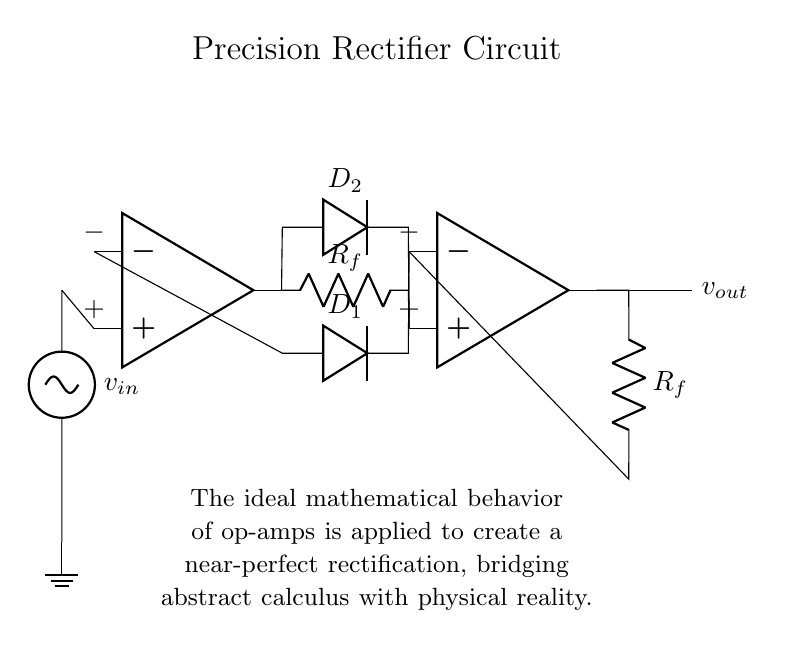What are the main components in this circuit? The circuit consists of two operational amplifiers, two diodes, and two resistors. The operational amplifiers amplify the input signal, while the diodes provide rectification. The resistors provide feedback in the circuit.
Answer: operational amplifiers, diodes, resistors What is the purpose of the diodes in this circuit? The diodes allow current to flow in one direction, effectively converting the AC input signal into a DC output signal, which is the function of a rectifier.
Answer: rectification How many operational amplifiers are used in this circuit? There are two operational amplifiers in the circuit, as indicated by the op-amp symbols shown in the diagram.
Answer: two What is the role of the feedback resistors in the circuit? The feedback resistors help set the gain of the operational amplifiers, thus controlling the output voltage relative to the input voltage. They ensure stability and linearity in the amplification process.
Answer: gain control What does the output voltage depend on? The output voltage depends on the input voltage, the gain set by the feedback resistors, and the operation of the diodes within the circuit. The output is a rectified version of the input signal.
Answer: input voltage and gain Why is this a precision rectifier circuit? This circuit is called a precision rectifier because it uses operational amplifiers to achieve rectification with high accuracy and low voltage drop across the diodes, effectively rectifying signals that would not be rectified by standard diode rectifiers.
Answer: high accuracy 